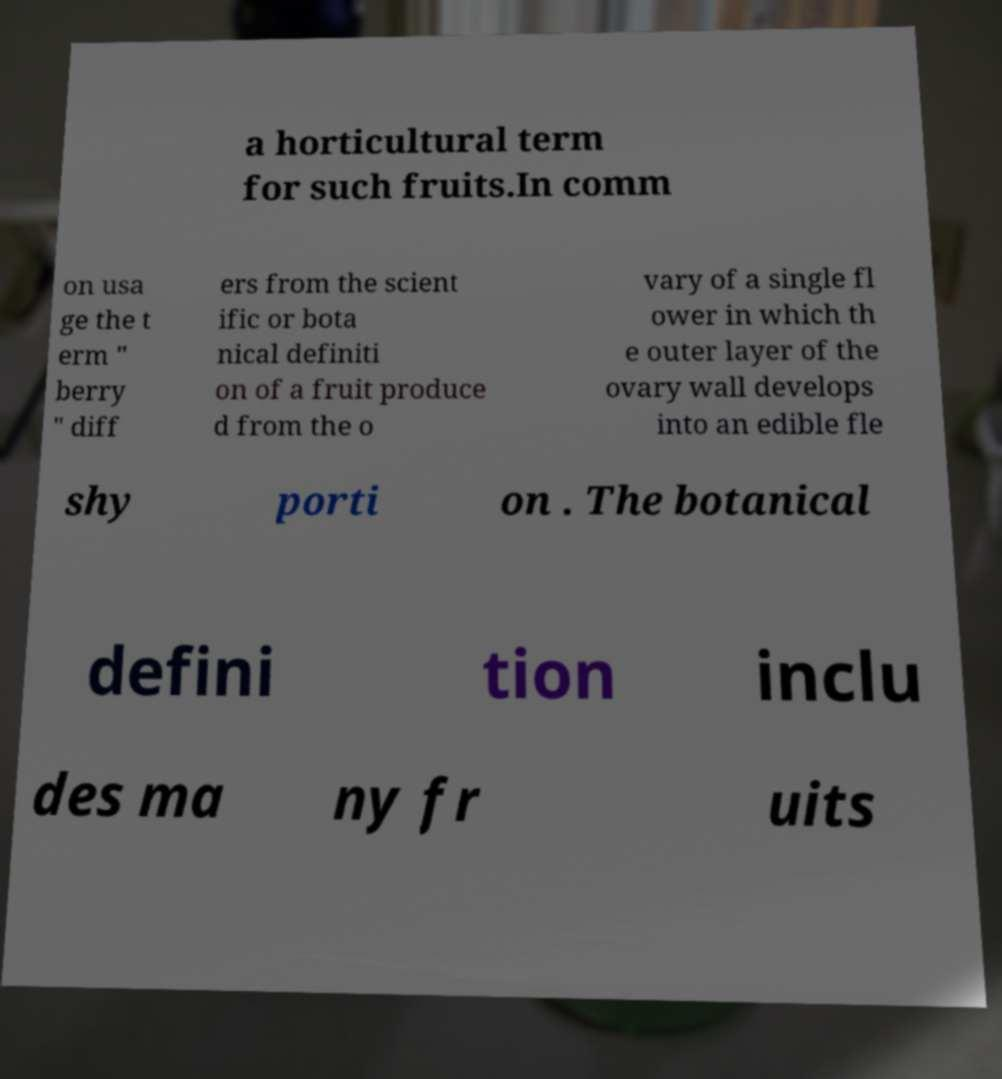There's text embedded in this image that I need extracted. Can you transcribe it verbatim? a horticultural term for such fruits.In comm on usa ge the t erm " berry " diff ers from the scient ific or bota nical definiti on of a fruit produce d from the o vary of a single fl ower in which th e outer layer of the ovary wall develops into an edible fle shy porti on . The botanical defini tion inclu des ma ny fr uits 